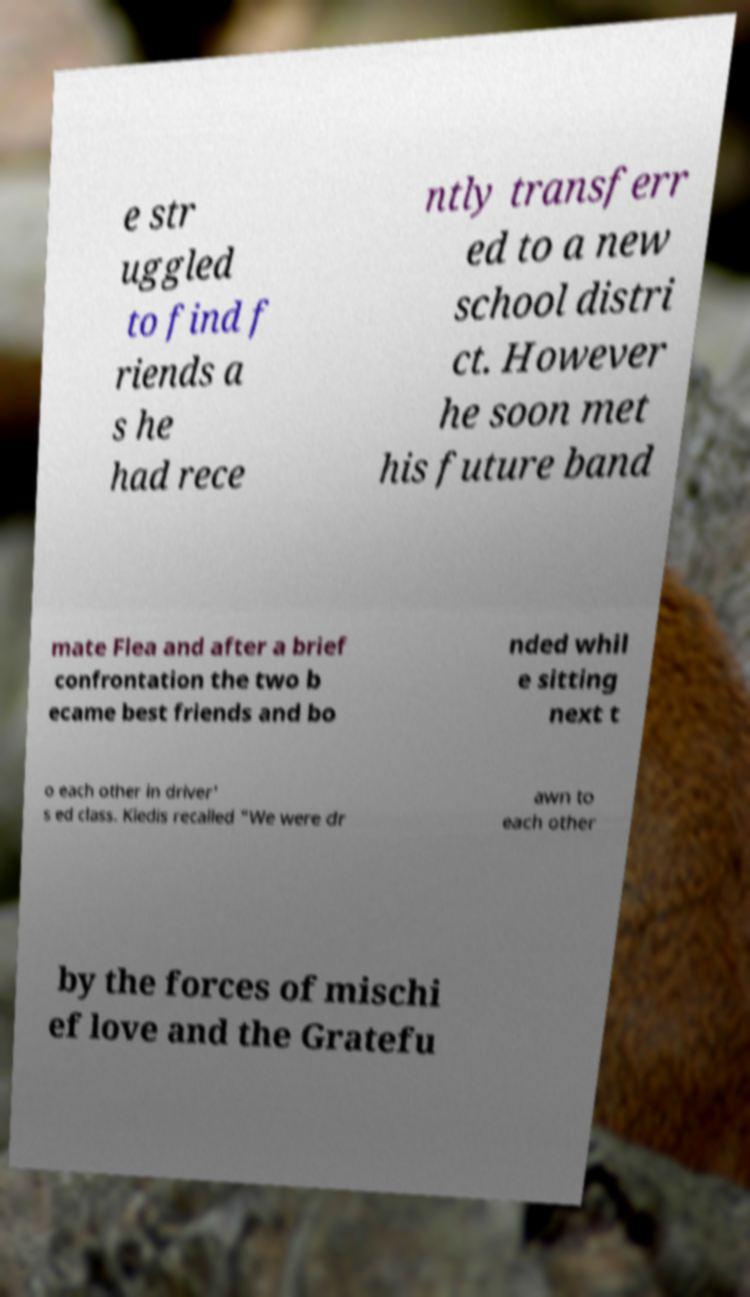Please read and relay the text visible in this image. What does it say? e str uggled to find f riends a s he had rece ntly transferr ed to a new school distri ct. However he soon met his future band mate Flea and after a brief confrontation the two b ecame best friends and bo nded whil e sitting next t o each other in driver' s ed class. Kiedis recalled "We were dr awn to each other by the forces of mischi ef love and the Gratefu 